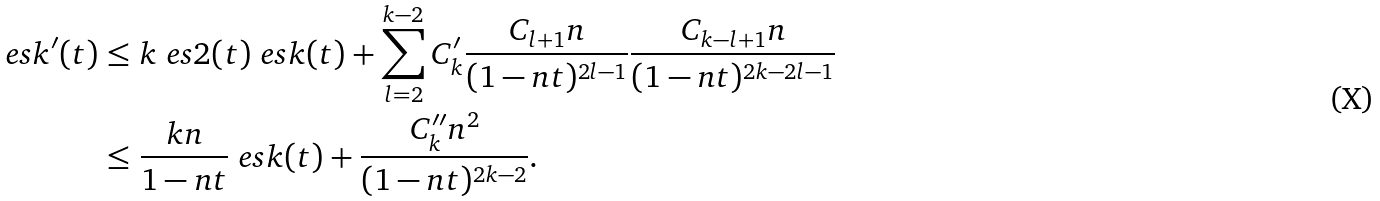<formula> <loc_0><loc_0><loc_500><loc_500>\ e s k ^ { \prime } ( t ) & \leq k \ e s 2 ( t ) \ e s k ( t ) + \sum _ { l = 2 } ^ { k - 2 } C _ { k } ^ { \prime } \frac { C _ { l + 1 } n } { ( 1 - n t ) ^ { 2 l - 1 } } \frac { C _ { k - l + 1 } n } { ( 1 - n t ) ^ { 2 k - 2 l - 1 } } \\ & \leq \frac { k n } { 1 - n t } \ e s k ( t ) + \frac { C ^ { \prime \prime } _ { k } n ^ { 2 } } { ( 1 - n t ) ^ { 2 k - 2 } } .</formula> 